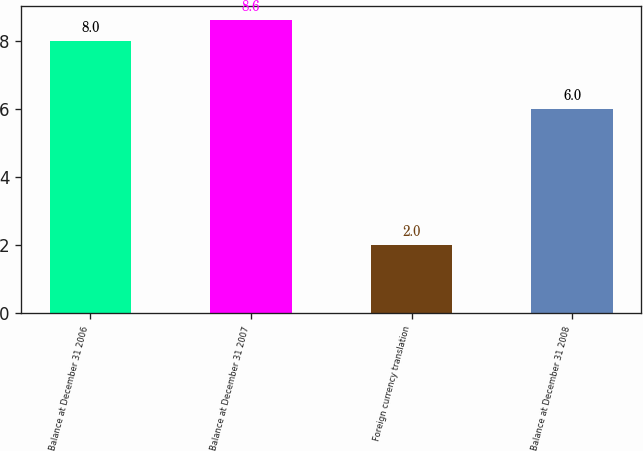Convert chart to OTSL. <chart><loc_0><loc_0><loc_500><loc_500><bar_chart><fcel>Balance at December 31 2006<fcel>Balance at December 31 2007<fcel>Foreign currency translation<fcel>Balance at December 31 2008<nl><fcel>8<fcel>8.6<fcel>2<fcel>6<nl></chart> 